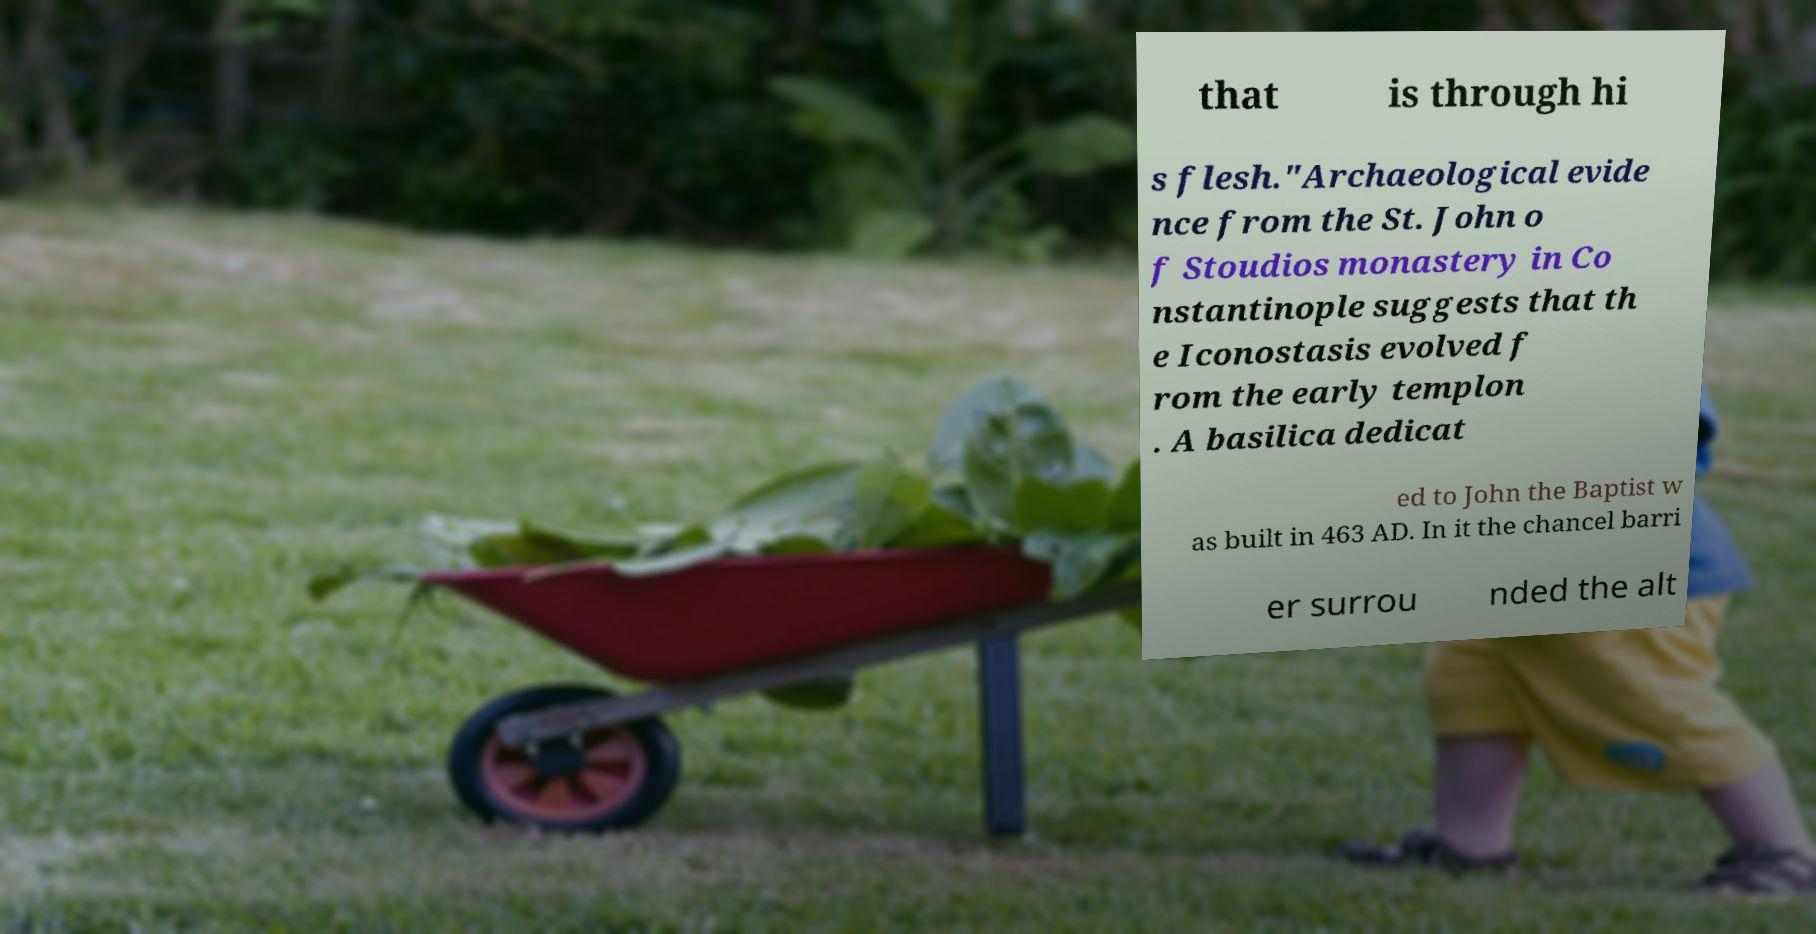What messages or text are displayed in this image? I need them in a readable, typed format. that is through hi s flesh."Archaeological evide nce from the St. John o f Stoudios monastery in Co nstantinople suggests that th e Iconostasis evolved f rom the early templon . A basilica dedicat ed to John the Baptist w as built in 463 AD. In it the chancel barri er surrou nded the alt 